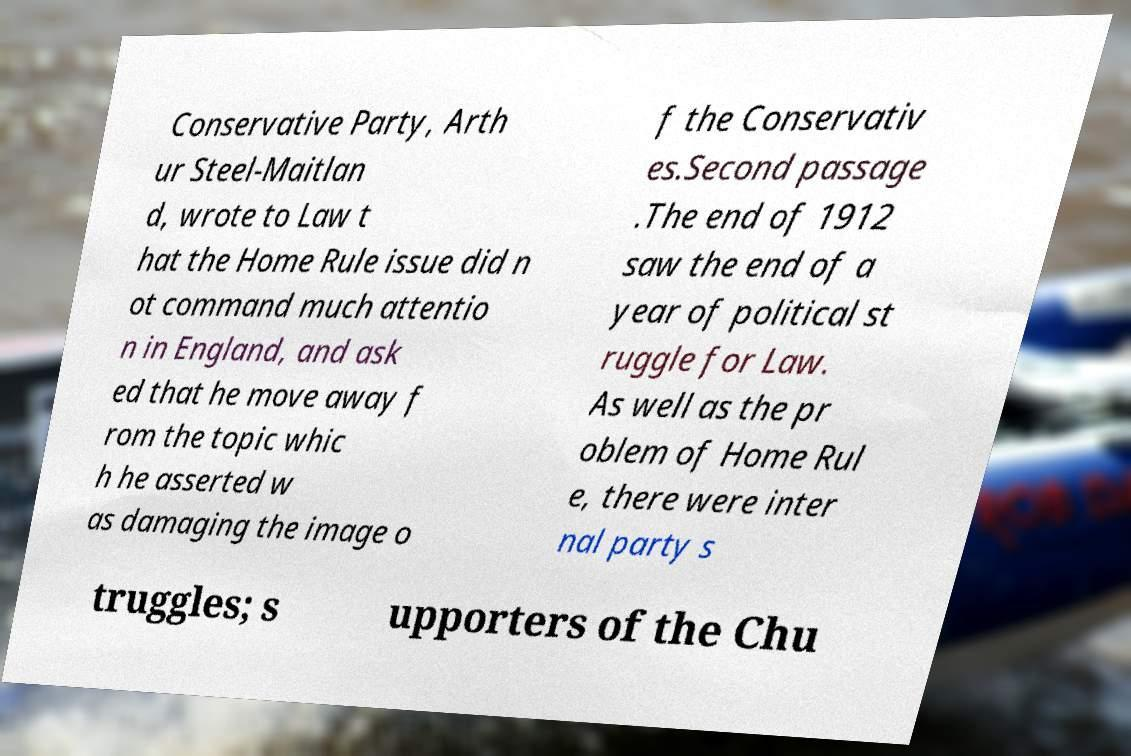Could you assist in decoding the text presented in this image and type it out clearly? Conservative Party, Arth ur Steel-Maitlan d, wrote to Law t hat the Home Rule issue did n ot command much attentio n in England, and ask ed that he move away f rom the topic whic h he asserted w as damaging the image o f the Conservativ es.Second passage .The end of 1912 saw the end of a year of political st ruggle for Law. As well as the pr oblem of Home Rul e, there were inter nal party s truggles; s upporters of the Chu 